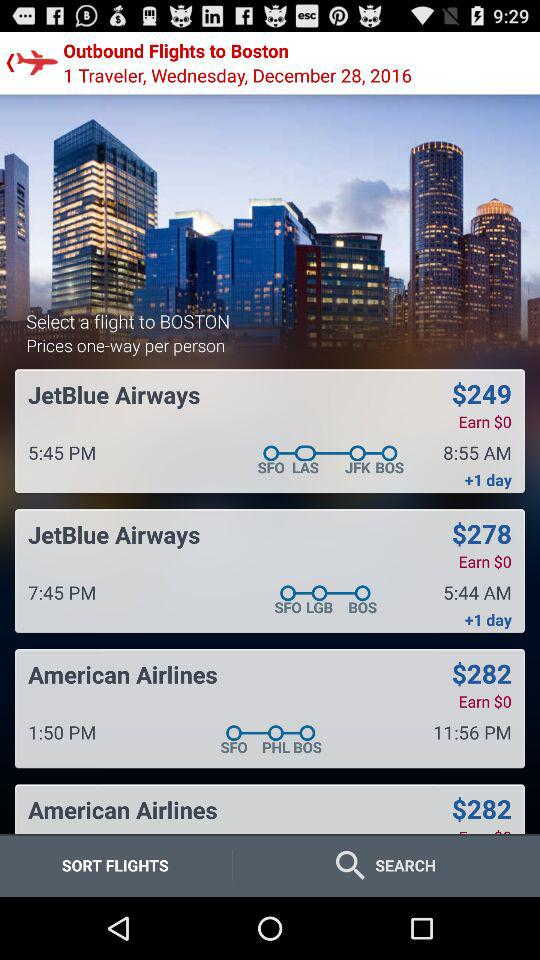What is the price for the "JetBlue Airways" ticket? The prices for the "JetBlue Airways" tickets are $249 and $278. 